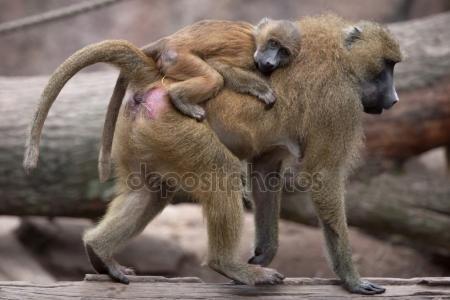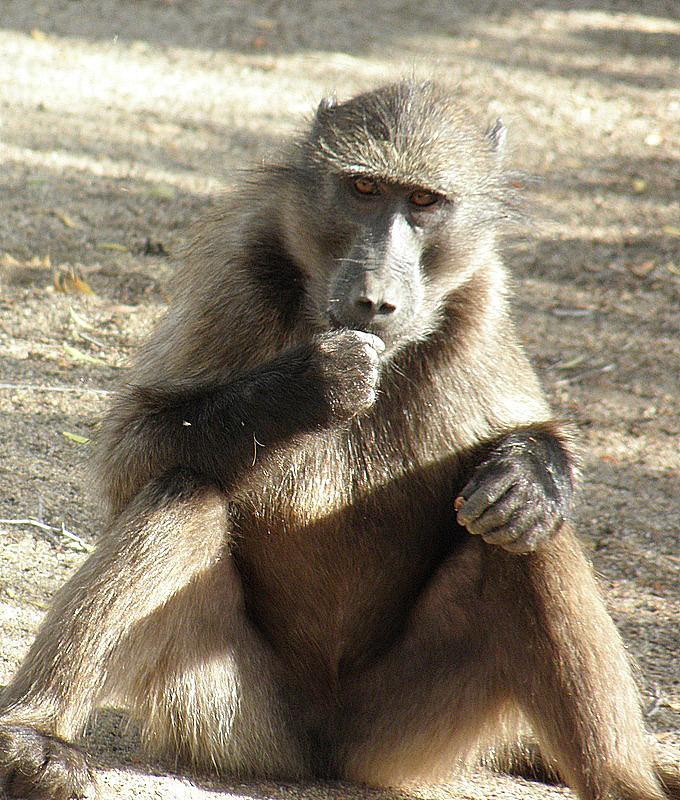The first image is the image on the left, the second image is the image on the right. Examine the images to the left and right. Is the description "An image includes one adult monkey on the right, and two sitting same-size juvenile monkeys on the left." accurate? Answer yes or no. No. The first image is the image on the left, the second image is the image on the right. Considering the images on both sides, is "There are at most 4 monkeys in total" valid? Answer yes or no. Yes. 